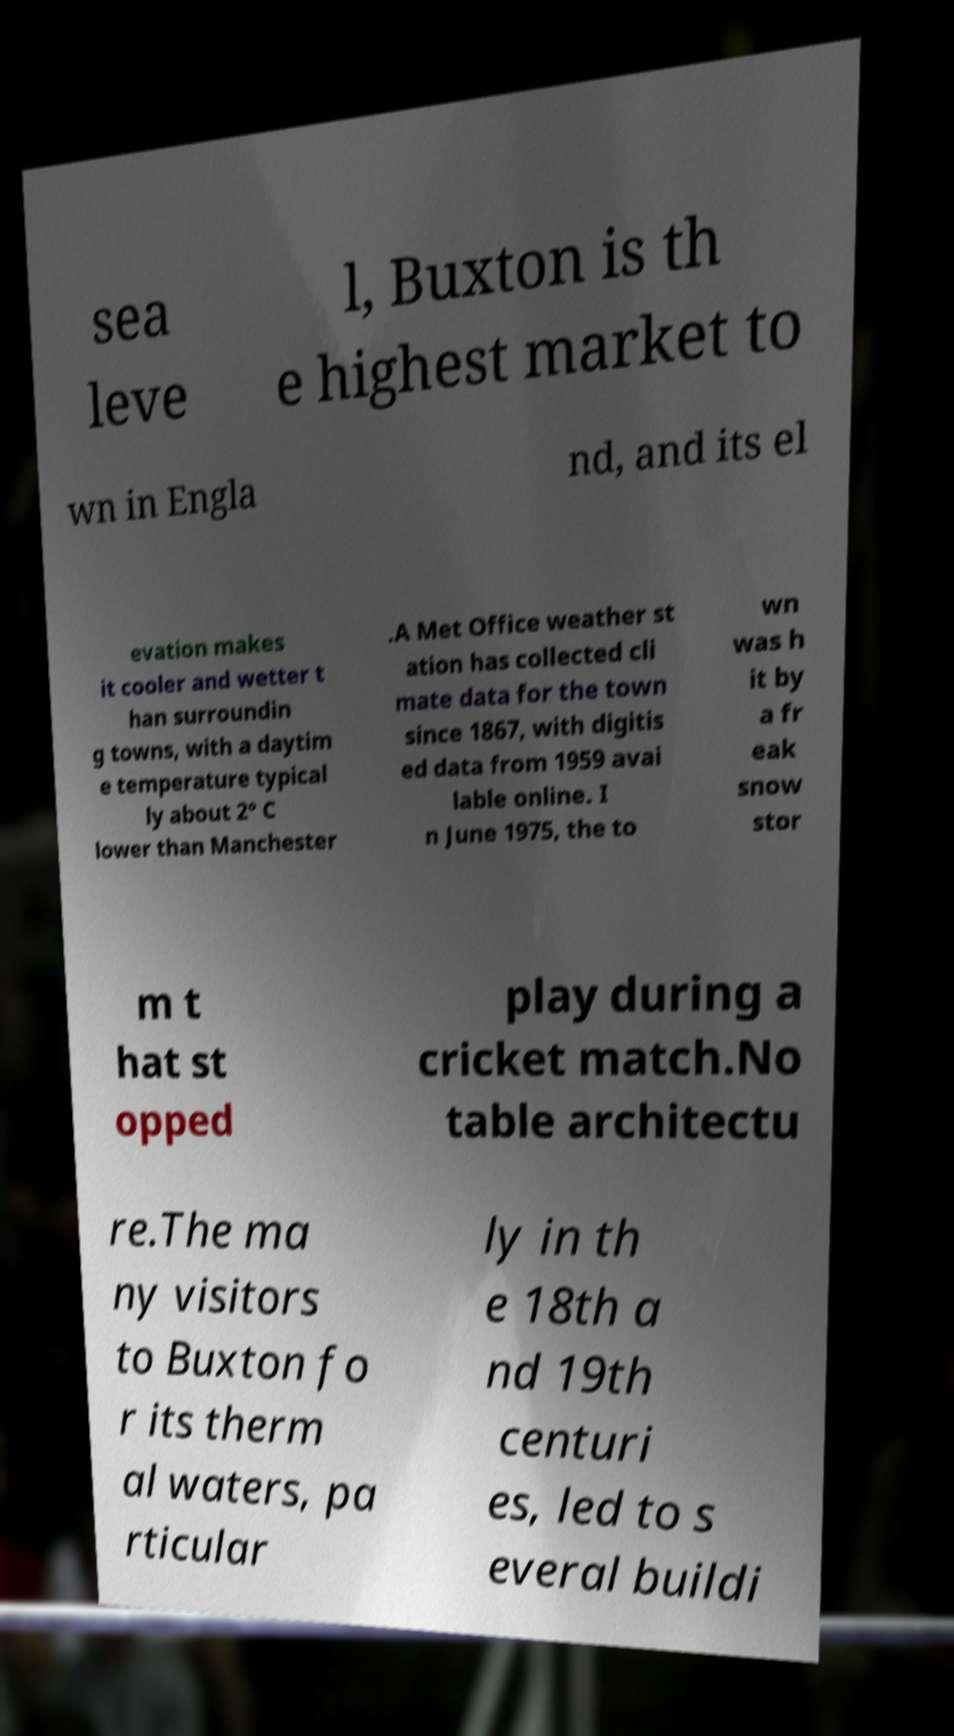Could you extract and type out the text from this image? sea leve l, Buxton is th e highest market to wn in Engla nd, and its el evation makes it cooler and wetter t han surroundin g towns, with a daytim e temperature typical ly about 2° C lower than Manchester .A Met Office weather st ation has collected cli mate data for the town since 1867, with digitis ed data from 1959 avai lable online. I n June 1975, the to wn was h it by a fr eak snow stor m t hat st opped play during a cricket match.No table architectu re.The ma ny visitors to Buxton fo r its therm al waters, pa rticular ly in th e 18th a nd 19th centuri es, led to s everal buildi 